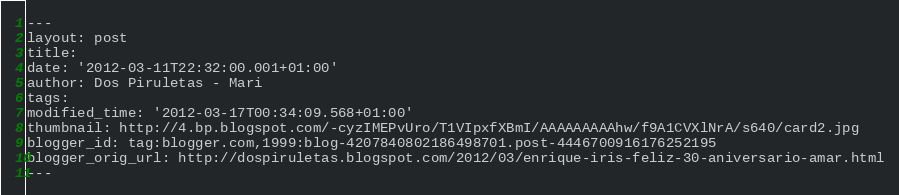Convert code to text. <code><loc_0><loc_0><loc_500><loc_500><_HTML_>---
layout: post
title: 
date: '2012-03-11T22:32:00.001+01:00'
author: Dos Piruletas - Mari
tags: 
modified_time: '2012-03-17T00:34:09.568+01:00'
thumbnail: http://4.bp.blogspot.com/-cyzIMEPvUro/T1VIpxfXBmI/AAAAAAAAAhw/f9A1CVXlNrA/s640/card2.jpg
blogger_id: tag:blogger.com,1999:blog-4207840802186498701.post-4446700916176252195
blogger_orig_url: http://dospiruletas.blogspot.com/2012/03/enrique-iris-feliz-30-aniversario-amar.html
---
</code> 